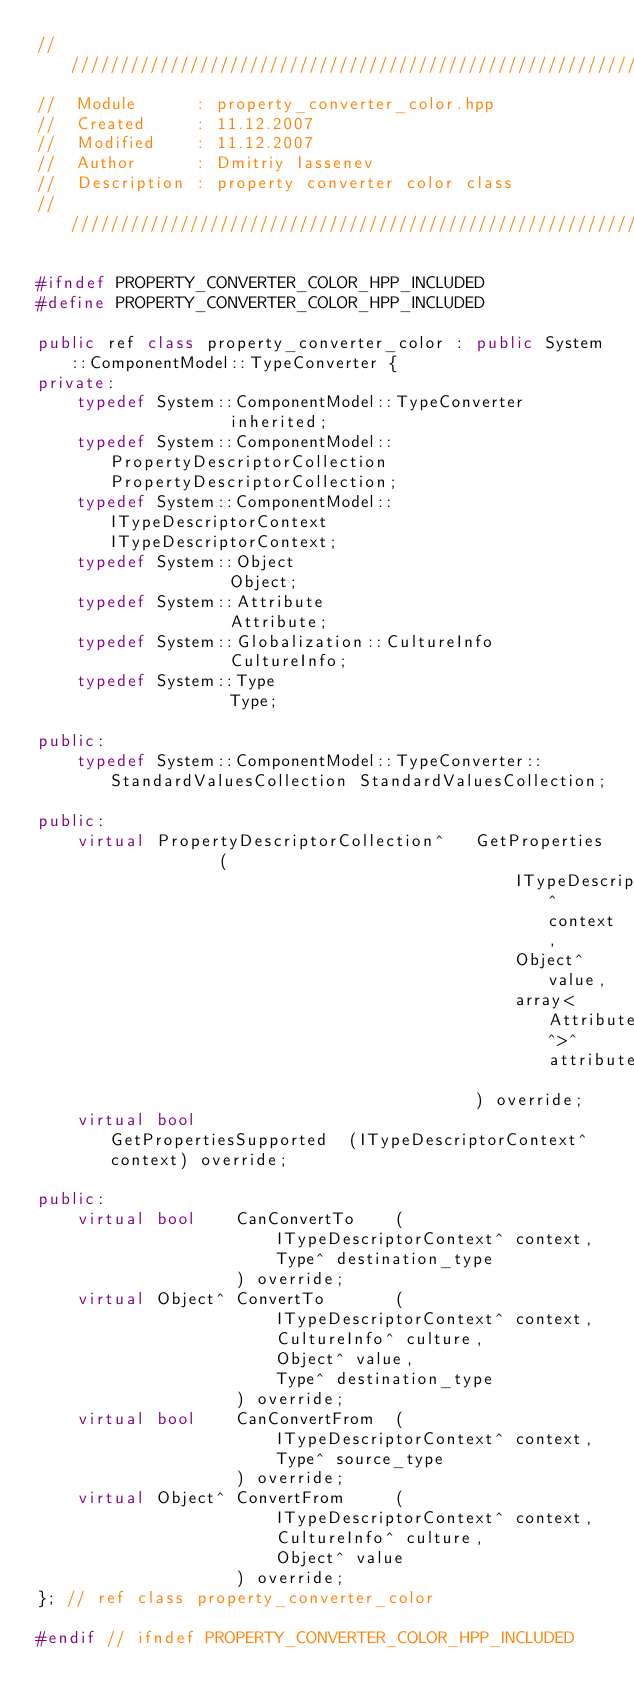<code> <loc_0><loc_0><loc_500><loc_500><_C++_>////////////////////////////////////////////////////////////////////////////
//	Module 		: property_converter_color.hpp
//	Created 	: 11.12.2007
//  Modified 	: 11.12.2007
//	Author		: Dmitriy Iassenev
//	Description : property converter color class
////////////////////////////////////////////////////////////////////////////

#ifndef PROPERTY_CONVERTER_COLOR_HPP_INCLUDED
#define PROPERTY_CONVERTER_COLOR_HPP_INCLUDED

public ref class property_converter_color : public System::ComponentModel::TypeConverter {
private:
	typedef System::ComponentModel::TypeConverter					inherited;
	typedef System::ComponentModel::PropertyDescriptorCollection	PropertyDescriptorCollection;
	typedef System::ComponentModel::ITypeDescriptorContext			ITypeDescriptorContext;
	typedef System::Object											Object;
	typedef System::Attribute										Attribute;
	typedef System::Globalization::CultureInfo						CultureInfo;
	typedef System::Type											Type;

public:
	typedef System::ComponentModel::TypeConverter::StandardValuesCollection	StandardValuesCollection;

public:
	virtual	PropertyDescriptorCollection^	GetProperties			(
												ITypeDescriptorContext^ context,
												Object^ value,
												array<Attribute^>^ attributes
											) override;
	virtual	bool							GetPropertiesSupported	(ITypeDescriptorContext^ context) override;

public:
	virtual	bool	CanConvertTo	(
						ITypeDescriptorContext^ context,
						Type^ destination_type
					) override;
	virtual Object^	ConvertTo		(
						ITypeDescriptorContext^ context,
						CultureInfo^ culture,
						Object^ value,
						Type^ destination_type
					) override;
	virtual	bool	CanConvertFrom	(
						ITypeDescriptorContext^ context,
						Type^ source_type
					) override;
	virtual Object^	ConvertFrom		(
						ITypeDescriptorContext^ context,
						CultureInfo^ culture,
						Object^ value
					) override;
}; // ref class property_converter_color

#endif // ifndef PROPERTY_CONVERTER_COLOR_HPP_INCLUDED</code> 